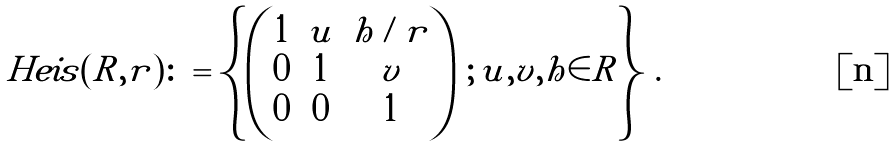<formula> <loc_0><loc_0><loc_500><loc_500>H e i s ( R , r ) \colon = \left \{ \begin{pmatrix} 1 & u & h / r \\ 0 & 1 & v \\ 0 & 0 & 1 \end{pmatrix} \, ; \, u , v , h \in R \right \} \, .</formula> 